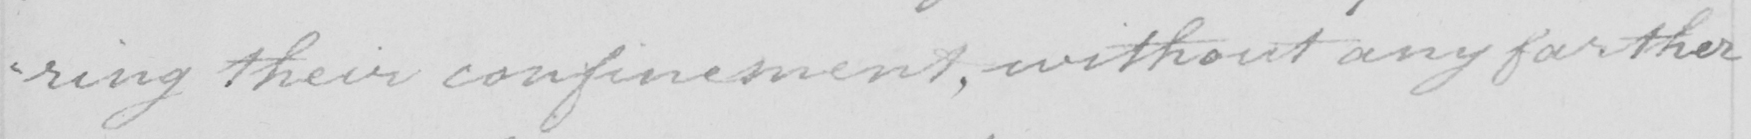Please transcribe the handwritten text in this image. -ring their confinement , without any farther 